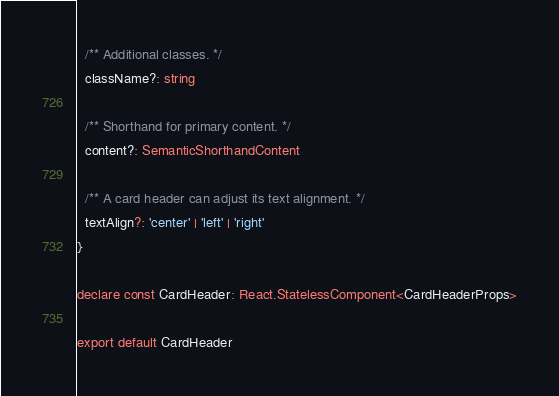Convert code to text. <code><loc_0><loc_0><loc_500><loc_500><_TypeScript_>
  /** Additional classes. */
  className?: string

  /** Shorthand for primary content. */
  content?: SemanticShorthandContent

  /** A card header can adjust its text alignment. */
  textAlign?: 'center' | 'left' | 'right'
}

declare const CardHeader: React.StatelessComponent<CardHeaderProps>

export default CardHeader
</code> 